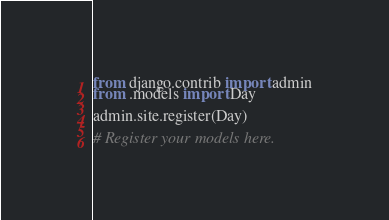Convert code to text. <code><loc_0><loc_0><loc_500><loc_500><_Python_>from django.contrib import admin
from .models import Day

admin.site.register(Day)

# Register your models here.
</code> 